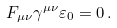Convert formula to latex. <formula><loc_0><loc_0><loc_500><loc_500>F _ { \mu \nu } \gamma ^ { \mu \nu } \varepsilon _ { 0 } = 0 \, .</formula> 